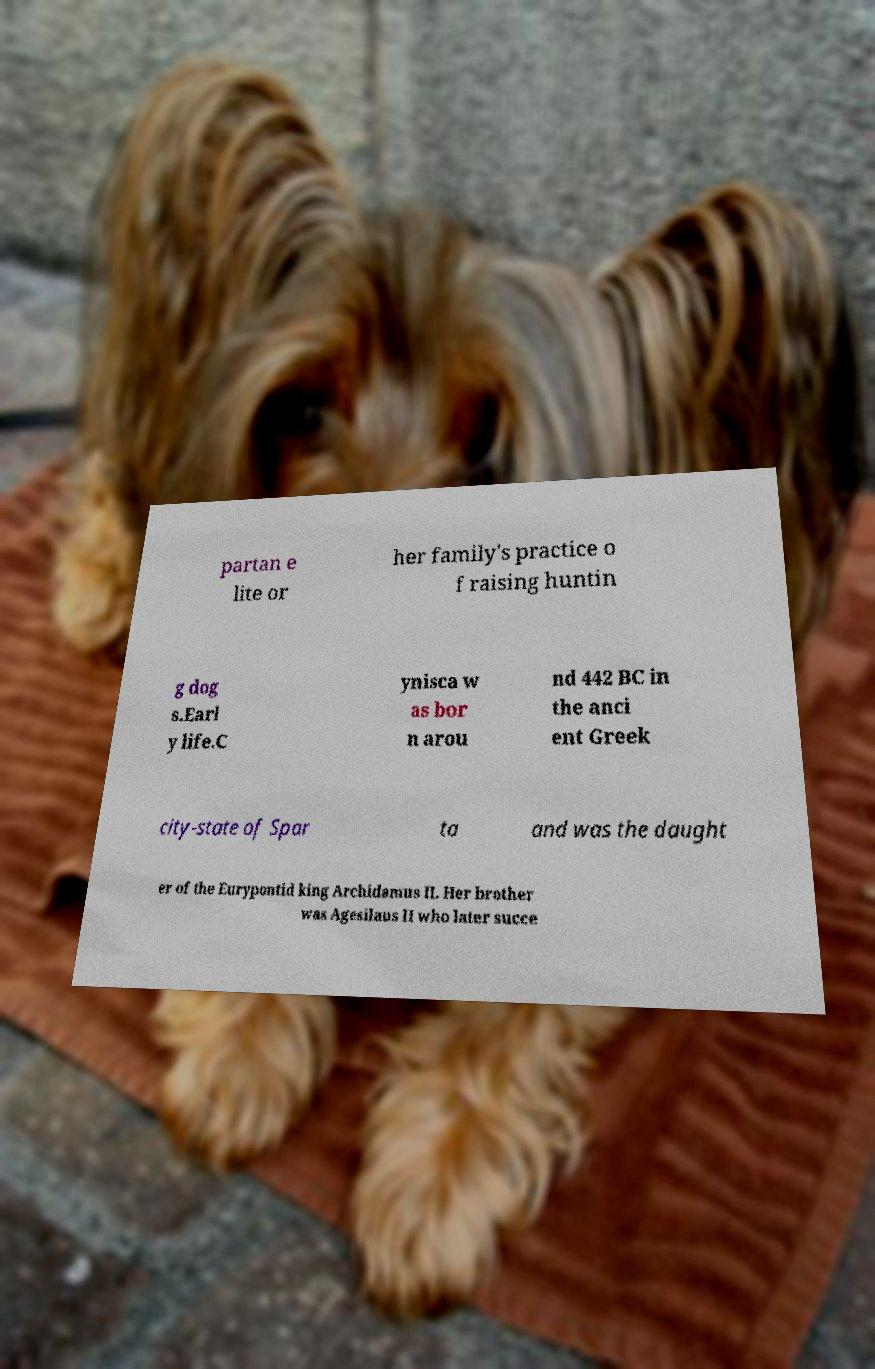For documentation purposes, I need the text within this image transcribed. Could you provide that? partan e lite or her family's practice o f raising huntin g dog s.Earl y life.C ynisca w as bor n arou nd 442 BC in the anci ent Greek city-state of Spar ta and was the daught er of the Eurypontid king Archidamus II. Her brother was Agesilaus II who later succe 